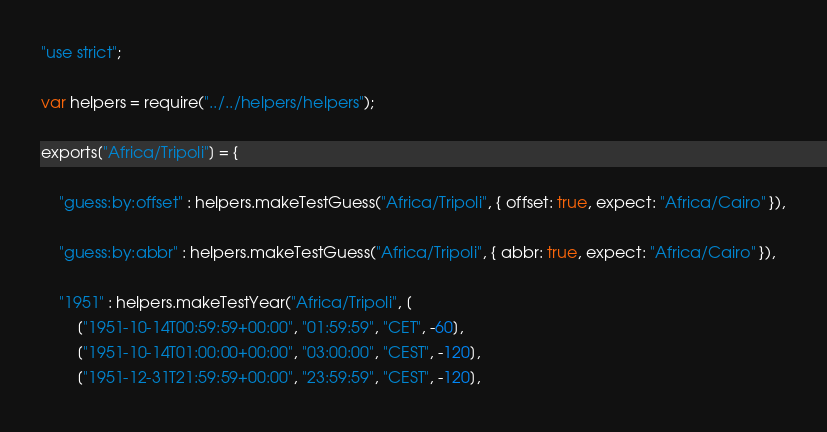<code> <loc_0><loc_0><loc_500><loc_500><_JavaScript_>"use strict";

var helpers = require("../../helpers/helpers");

exports["Africa/Tripoli"] = {

	"guess:by:offset" : helpers.makeTestGuess("Africa/Tripoli", { offset: true, expect: "Africa/Cairo" }),

	"guess:by:abbr" : helpers.makeTestGuess("Africa/Tripoli", { abbr: true, expect: "Africa/Cairo" }),

	"1951" : helpers.makeTestYear("Africa/Tripoli", [
		["1951-10-14T00:59:59+00:00", "01:59:59", "CET", -60],
		["1951-10-14T01:00:00+00:00", "03:00:00", "CEST", -120],
		["1951-12-31T21:59:59+00:00", "23:59:59", "CEST", -120],</code> 